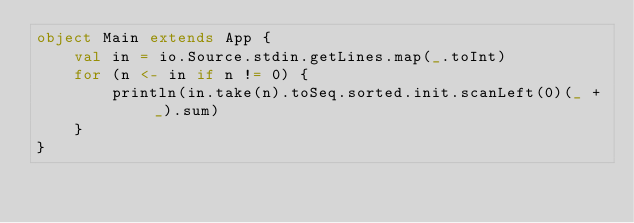Convert code to text. <code><loc_0><loc_0><loc_500><loc_500><_Scala_>object Main extends App {
    val in = io.Source.stdin.getLines.map(_.toInt)
    for (n <- in if n != 0) {
        println(in.take(n).toSeq.sorted.init.scanLeft(0)(_ + _).sum)
    }
}</code> 